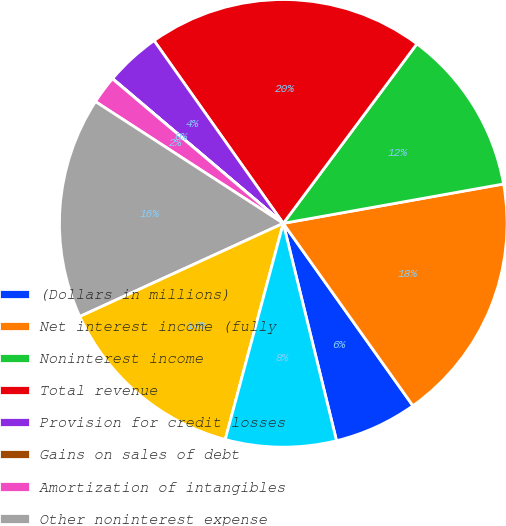<chart> <loc_0><loc_0><loc_500><loc_500><pie_chart><fcel>(Dollars in millions)<fcel>Net interest income (fully<fcel>Noninterest income<fcel>Total revenue<fcel>Provision for credit losses<fcel>Gains on sales of debt<fcel>Amortization of intangibles<fcel>Other noninterest expense<fcel>Income before income taxes<fcel>Income tax expense<nl><fcel>6.01%<fcel>17.98%<fcel>12.0%<fcel>19.98%<fcel>4.01%<fcel>0.02%<fcel>2.02%<fcel>15.99%<fcel>13.99%<fcel>8.0%<nl></chart> 